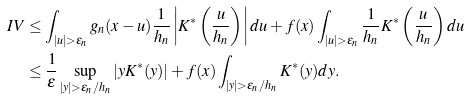<formula> <loc_0><loc_0><loc_500><loc_500>I V & \leq \int _ { | u | > \epsilon _ { n } } g _ { n } ( x - u ) \frac { 1 } { h _ { n } } \left | K ^ { * } \left ( \frac { u } { h _ { n } } \right ) \right | d u + f ( x ) \int _ { | u | > \epsilon _ { n } } \frac { 1 } { h _ { n } } K ^ { * } \left ( \frac { u } { h _ { n } } \right ) d u \\ & \leq \frac { 1 } { \epsilon } \sup _ { | y | > \epsilon _ { n } / h _ { n } } | y K ^ { * } ( y ) | + f ( x ) \int _ { | y | > \epsilon _ { n } / h _ { n } } K ^ { * } ( y ) d y .</formula> 